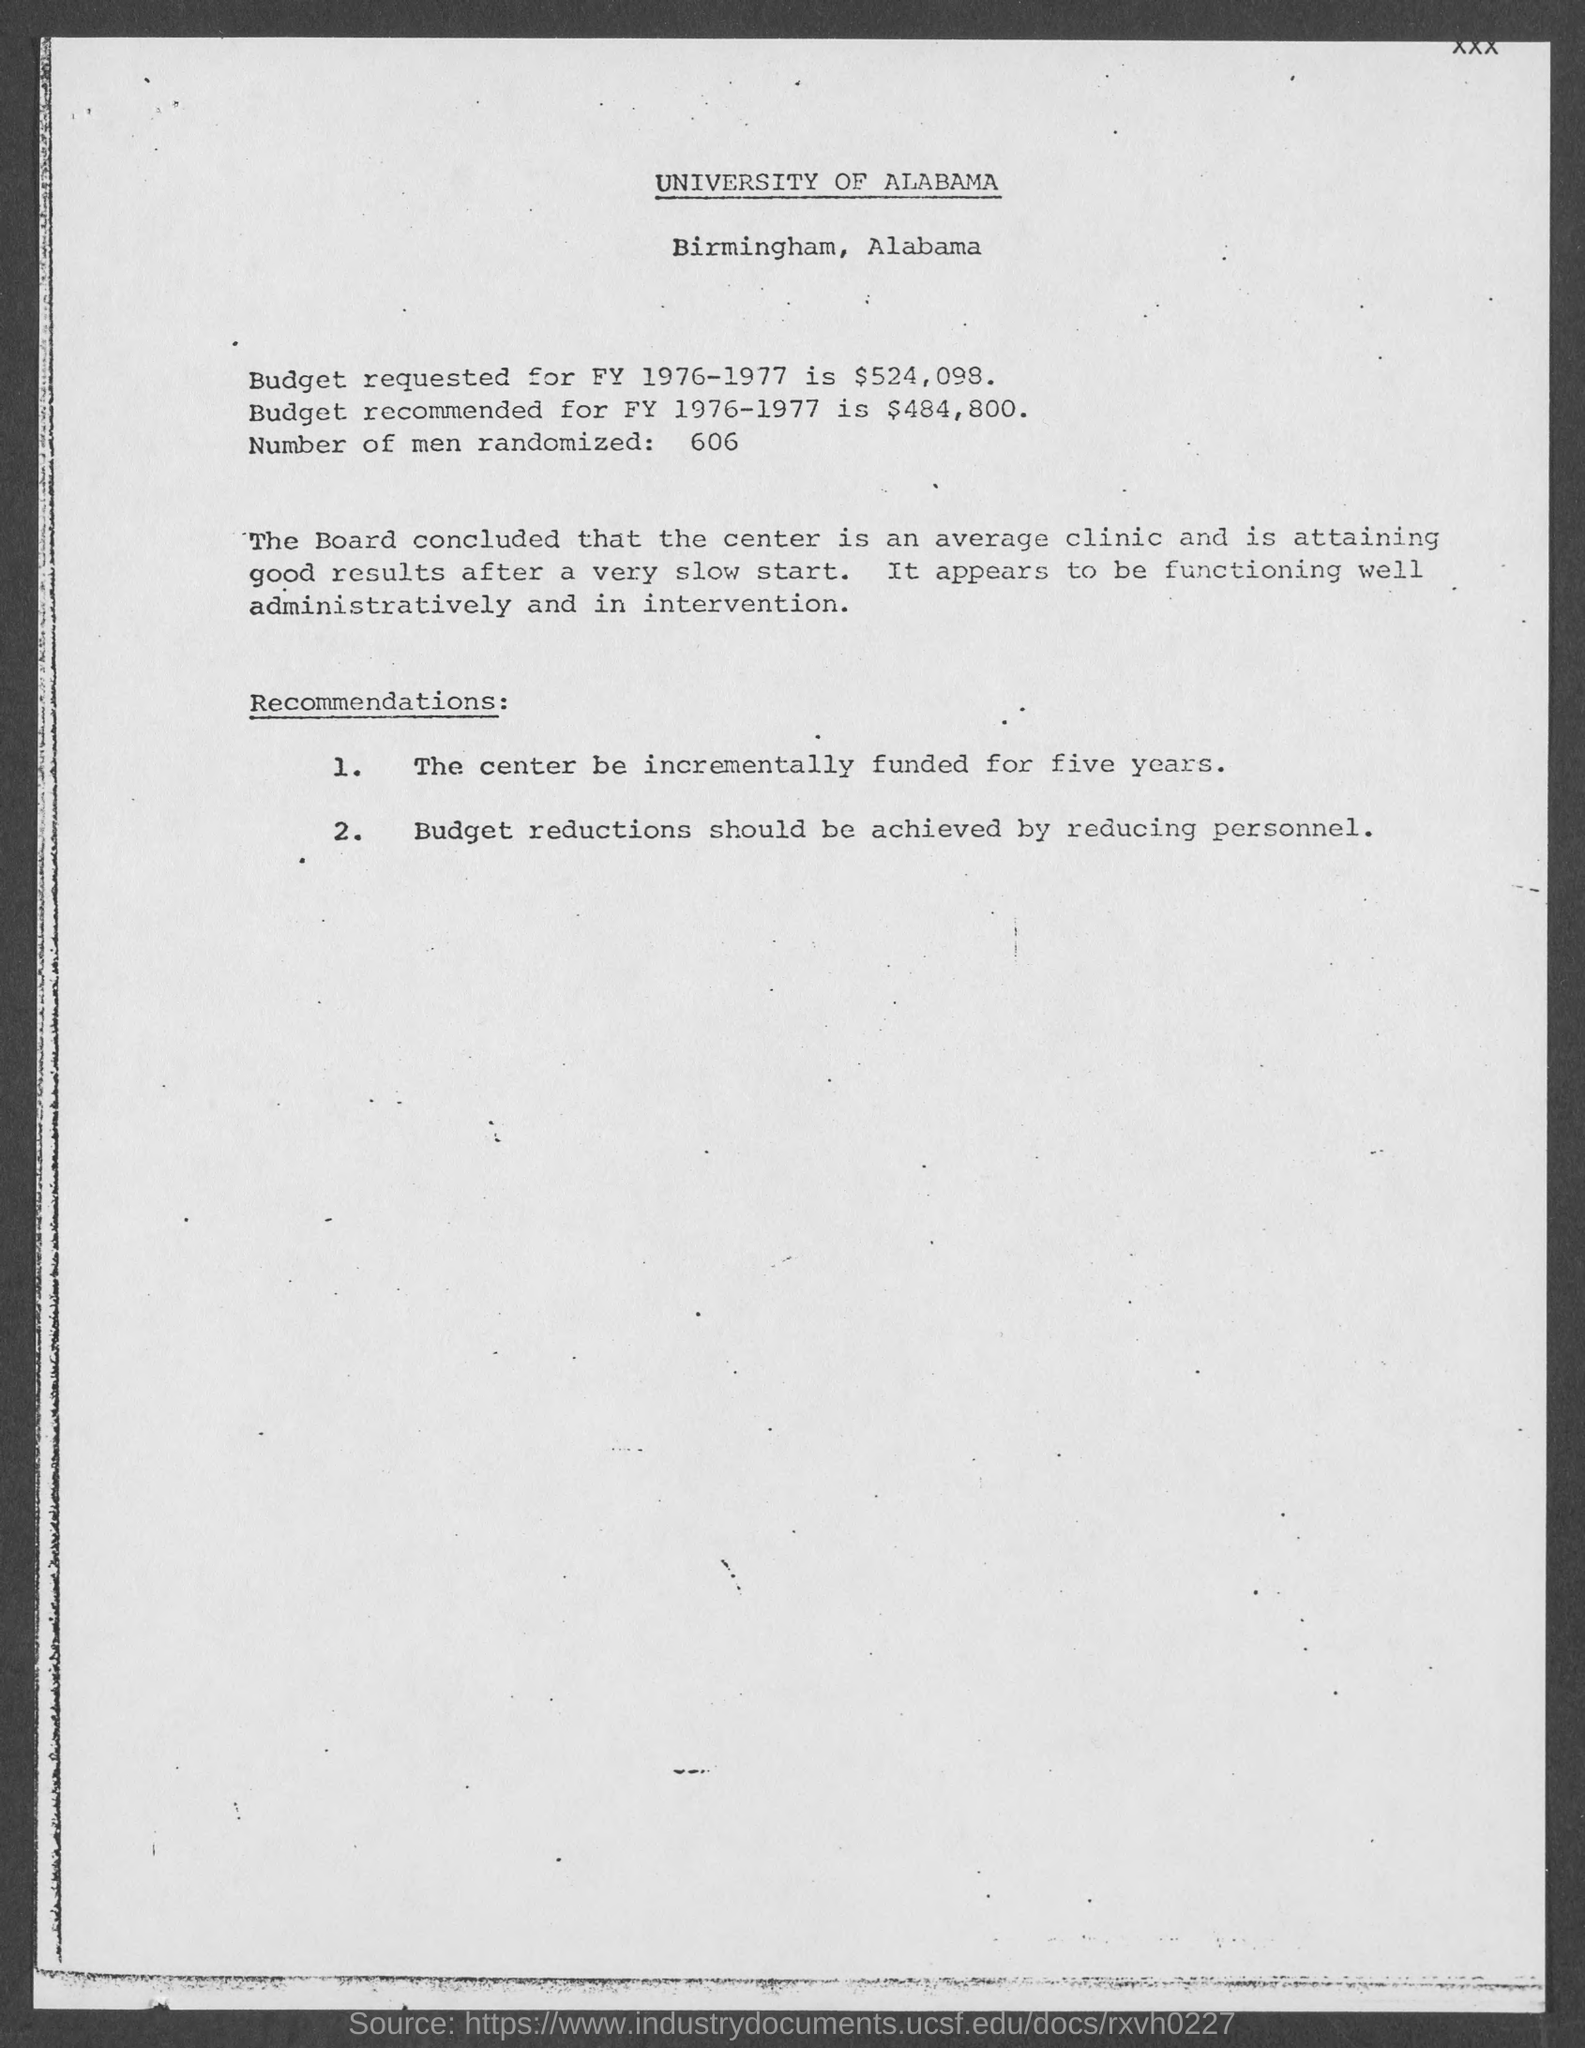Draw attention to some important aspects in this diagram. The budget requested for fiscal year 1976-1977 is $524,098. The University of Alabama is mentioned in this document. Out of the 606 participants randomized, the number of men was X. The University of Alabama is situated in Birmingham, Alabama. For Fiscal Year 1976-1977, the recommended budget is $484,800. 